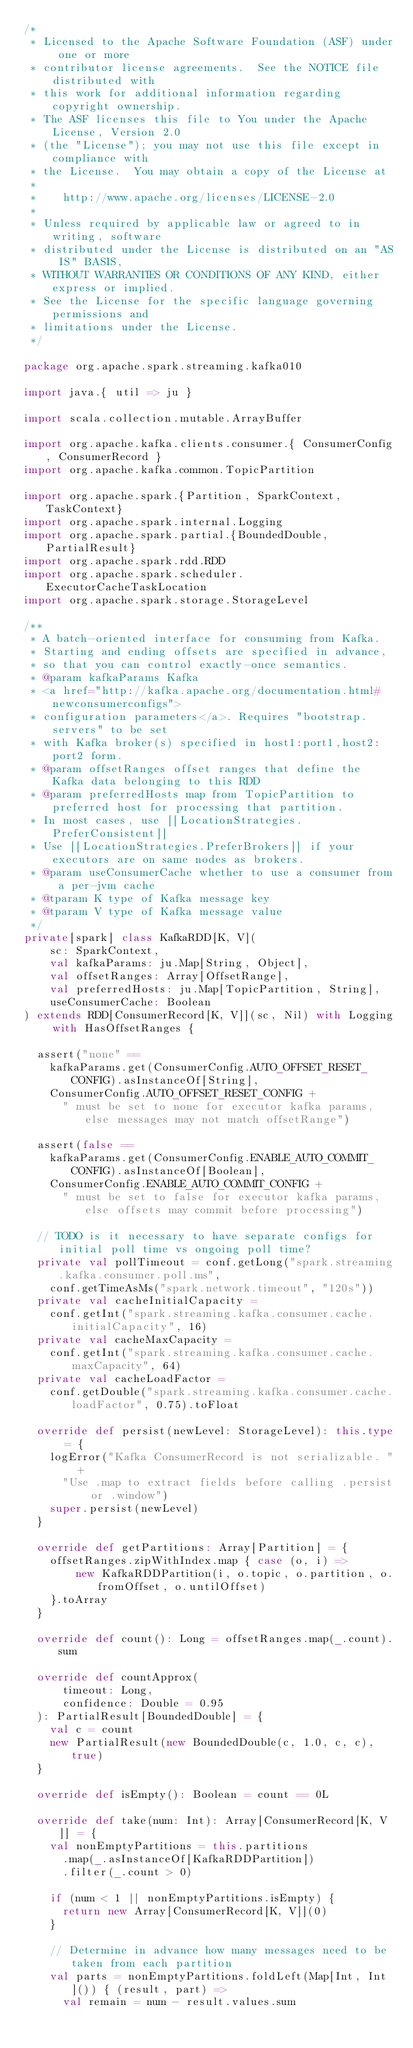<code> <loc_0><loc_0><loc_500><loc_500><_Scala_>/*
 * Licensed to the Apache Software Foundation (ASF) under one or more
 * contributor license agreements.  See the NOTICE file distributed with
 * this work for additional information regarding copyright ownership.
 * The ASF licenses this file to You under the Apache License, Version 2.0
 * (the "License"); you may not use this file except in compliance with
 * the License.  You may obtain a copy of the License at
 *
 *    http://www.apache.org/licenses/LICENSE-2.0
 *
 * Unless required by applicable law or agreed to in writing, software
 * distributed under the License is distributed on an "AS IS" BASIS,
 * WITHOUT WARRANTIES OR CONDITIONS OF ANY KIND, either express or implied.
 * See the License for the specific language governing permissions and
 * limitations under the License.
 */

package org.apache.spark.streaming.kafka010

import java.{ util => ju }

import scala.collection.mutable.ArrayBuffer

import org.apache.kafka.clients.consumer.{ ConsumerConfig, ConsumerRecord }
import org.apache.kafka.common.TopicPartition

import org.apache.spark.{Partition, SparkContext, TaskContext}
import org.apache.spark.internal.Logging
import org.apache.spark.partial.{BoundedDouble, PartialResult}
import org.apache.spark.rdd.RDD
import org.apache.spark.scheduler.ExecutorCacheTaskLocation
import org.apache.spark.storage.StorageLevel

/**
 * A batch-oriented interface for consuming from Kafka.
 * Starting and ending offsets are specified in advance,
 * so that you can control exactly-once semantics.
 * @param kafkaParams Kafka
 * <a href="http://kafka.apache.org/documentation.html#newconsumerconfigs">
 * configuration parameters</a>. Requires "bootstrap.servers" to be set
 * with Kafka broker(s) specified in host1:port1,host2:port2 form.
 * @param offsetRanges offset ranges that define the Kafka data belonging to this RDD
 * @param preferredHosts map from TopicPartition to preferred host for processing that partition.
 * In most cases, use [[LocationStrategies.PreferConsistent]]
 * Use [[LocationStrategies.PreferBrokers]] if your executors are on same nodes as brokers.
 * @param useConsumerCache whether to use a consumer from a per-jvm cache
 * @tparam K type of Kafka message key
 * @tparam V type of Kafka message value
 */
private[spark] class KafkaRDD[K, V](
    sc: SparkContext,
    val kafkaParams: ju.Map[String, Object],
    val offsetRanges: Array[OffsetRange],
    val preferredHosts: ju.Map[TopicPartition, String],
    useConsumerCache: Boolean
) extends RDD[ConsumerRecord[K, V]](sc, Nil) with Logging with HasOffsetRanges {

  assert("none" ==
    kafkaParams.get(ConsumerConfig.AUTO_OFFSET_RESET_CONFIG).asInstanceOf[String],
    ConsumerConfig.AUTO_OFFSET_RESET_CONFIG +
      " must be set to none for executor kafka params, else messages may not match offsetRange")

  assert(false ==
    kafkaParams.get(ConsumerConfig.ENABLE_AUTO_COMMIT_CONFIG).asInstanceOf[Boolean],
    ConsumerConfig.ENABLE_AUTO_COMMIT_CONFIG +
      " must be set to false for executor kafka params, else offsets may commit before processing")

  // TODO is it necessary to have separate configs for initial poll time vs ongoing poll time?
  private val pollTimeout = conf.getLong("spark.streaming.kafka.consumer.poll.ms",
    conf.getTimeAsMs("spark.network.timeout", "120s"))
  private val cacheInitialCapacity =
    conf.getInt("spark.streaming.kafka.consumer.cache.initialCapacity", 16)
  private val cacheMaxCapacity =
    conf.getInt("spark.streaming.kafka.consumer.cache.maxCapacity", 64)
  private val cacheLoadFactor =
    conf.getDouble("spark.streaming.kafka.consumer.cache.loadFactor", 0.75).toFloat

  override def persist(newLevel: StorageLevel): this.type = {
    logError("Kafka ConsumerRecord is not serializable. " +
      "Use .map to extract fields before calling .persist or .window")
    super.persist(newLevel)
  }

  override def getPartitions: Array[Partition] = {
    offsetRanges.zipWithIndex.map { case (o, i) =>
        new KafkaRDDPartition(i, o.topic, o.partition, o.fromOffset, o.untilOffset)
    }.toArray
  }

  override def count(): Long = offsetRanges.map(_.count).sum

  override def countApprox(
      timeout: Long,
      confidence: Double = 0.95
  ): PartialResult[BoundedDouble] = {
    val c = count
    new PartialResult(new BoundedDouble(c, 1.0, c, c), true)
  }

  override def isEmpty(): Boolean = count == 0L

  override def take(num: Int): Array[ConsumerRecord[K, V]] = {
    val nonEmptyPartitions = this.partitions
      .map(_.asInstanceOf[KafkaRDDPartition])
      .filter(_.count > 0)

    if (num < 1 || nonEmptyPartitions.isEmpty) {
      return new Array[ConsumerRecord[K, V]](0)
    }

    // Determine in advance how many messages need to be taken from each partition
    val parts = nonEmptyPartitions.foldLeft(Map[Int, Int]()) { (result, part) =>
      val remain = num - result.values.sum</code> 